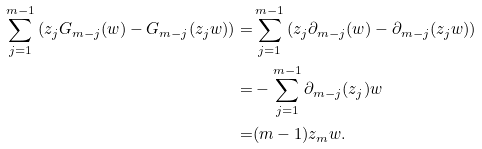<formula> <loc_0><loc_0><loc_500><loc_500>\sum _ { j = 1 } ^ { m - 1 } \left ( z _ { j } G _ { m - j } ( w ) - G _ { m - j } ( z _ { j } w ) \right ) = & \sum _ { j = 1 } ^ { m - 1 } \left ( z _ { j } \partial _ { m - j } ( w ) - \partial _ { m - j } ( z _ { j } w ) \right ) \\ = & - \sum _ { j = 1 } ^ { m - 1 } \partial _ { m - j } ( z _ { j } ) w \\ = & ( m - 1 ) z _ { m } w .</formula> 